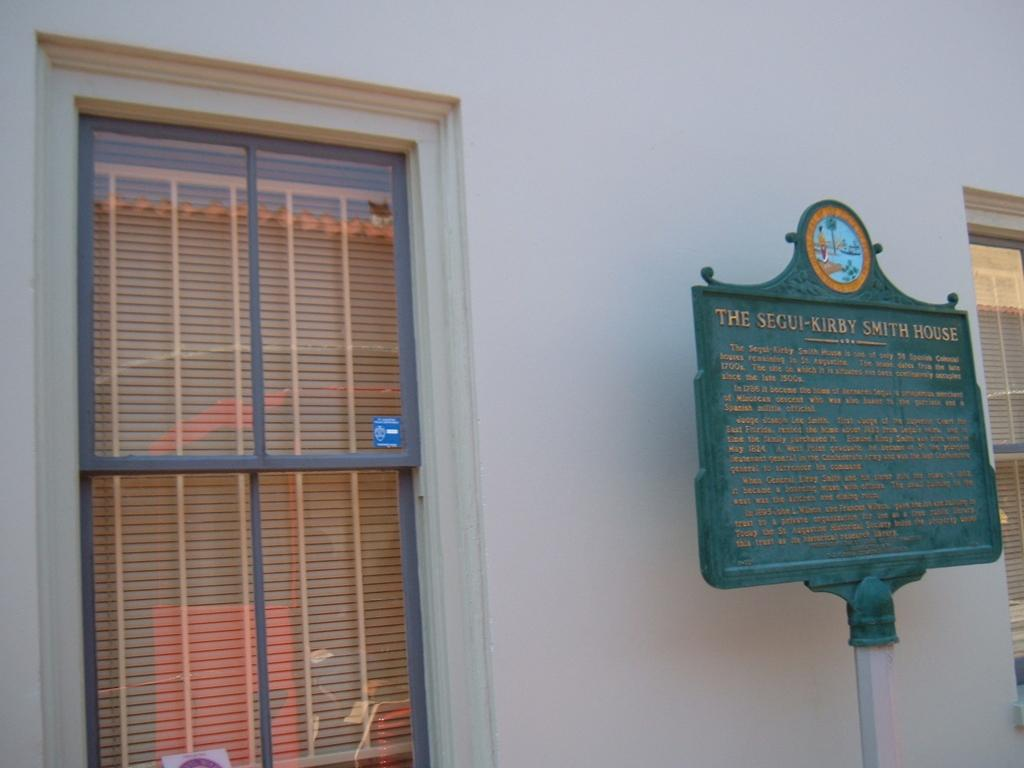Provide a one-sentence caption for the provided image. An information sign informing the name of a building as the Segui-Kirby Smith House. 